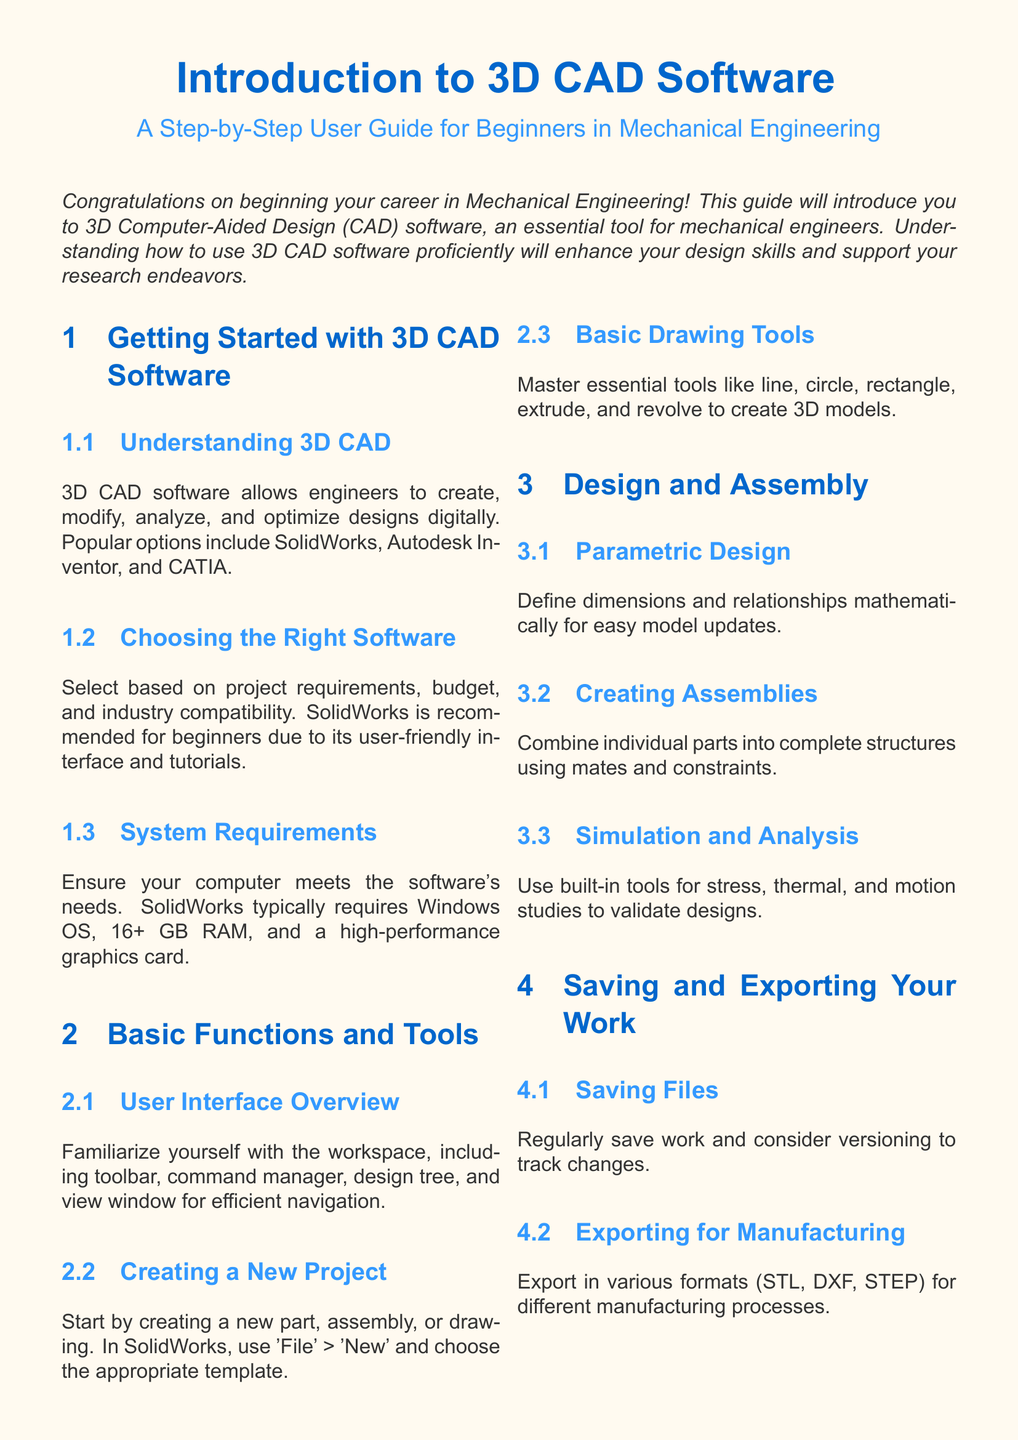What are popular options for 3D CAD software? The document lists SolidWorks, Autodesk Inventor, and CATIA as popular options for 3D CAD software.
Answer: SolidWorks, Autodesk Inventor, CATIA What is recommended for beginners? The text suggests that SolidWorks is recommended for beginners due to its user-friendly interface and tutorials.
Answer: SolidWorks What is the typical RAM requirement for SolidWorks? According to the document, SolidWorks typically requires 16+ GB RAM.
Answer: 16+ GB RAM What is a key feature of parametric design? The document states that parametric design allows for defining dimensions and relationships mathematically for easy model updates.
Answer: Mathematical definitions What types of simulations can be conducted in 3D CAD software? The guide mentions stress, thermal, and motion studies as types of simulations.
Answer: Stress, thermal, motion studies What is the main purpose of 3D CAD software? The document explains that 3D CAD software allows engineers to create, modify, analyze, and optimize designs digitally.
Answer: Create, modify, analyze, optimize designs How often should you save your work? The document suggests regularly saving work and considering versioning to track changes.
Answer: Regularly What should you do to start a new project in SolidWorks? To create a new project, you should use 'File' > 'New' and choose the appropriate template.
Answer: 'File' > 'New' What format can be used for exporting files? The document states that files can be exported in formats such as STL, DXF, and STEP.
Answer: STL, DXF, STEP 